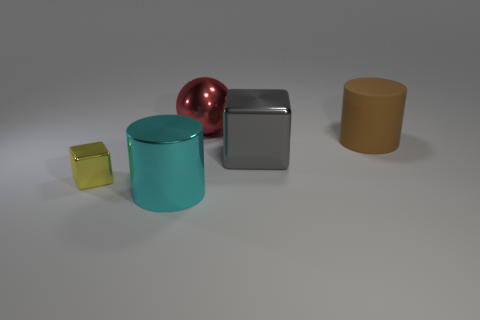Add 2 big purple spheres. How many objects exist? 7 Subtract all cylinders. How many objects are left? 3 Subtract all cyan cylinders. Subtract all brown matte things. How many objects are left? 3 Add 3 brown matte objects. How many brown matte objects are left? 4 Add 1 large rubber things. How many large rubber things exist? 2 Subtract 0 brown blocks. How many objects are left? 5 